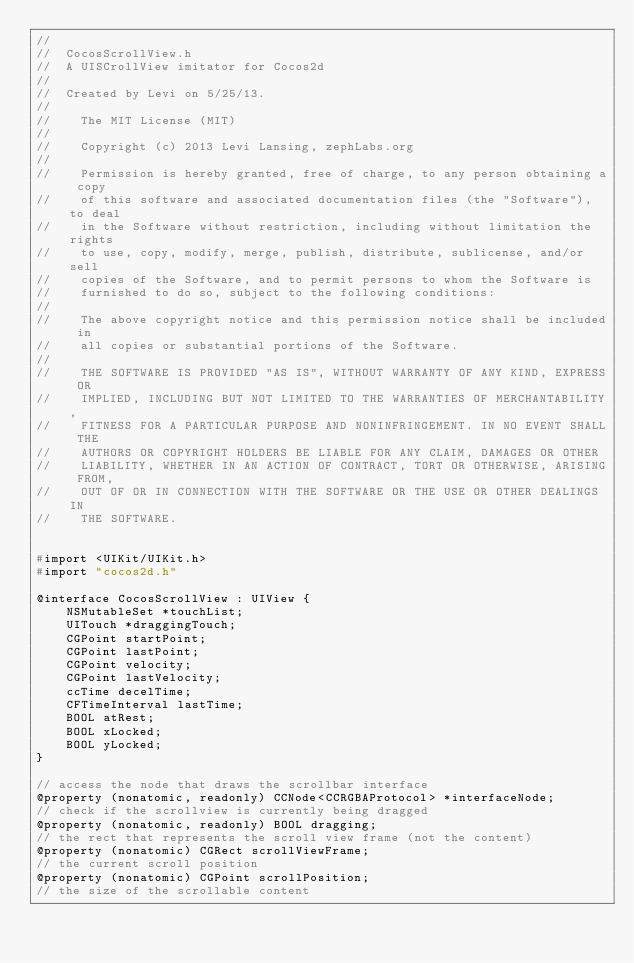Convert code to text. <code><loc_0><loc_0><loc_500><loc_500><_C_>//
//  CocosScrollView.h
//  A UISCrollView imitator for Cocos2d
//
//  Created by Levi on 5/25/13.
//
//    The MIT License (MIT)
//
//    Copyright (c) 2013 Levi Lansing, zephLabs.org
//
//    Permission is hereby granted, free of charge, to any person obtaining a copy
//    of this software and associated documentation files (the "Software"), to deal
//    in the Software without restriction, including without limitation the rights
//    to use, copy, modify, merge, publish, distribute, sublicense, and/or sell
//    copies of the Software, and to permit persons to whom the Software is
//    furnished to do so, subject to the following conditions:
//
//    The above copyright notice and this permission notice shall be included in
//    all copies or substantial portions of the Software.
//
//    THE SOFTWARE IS PROVIDED "AS IS", WITHOUT WARRANTY OF ANY KIND, EXPRESS OR
//    IMPLIED, INCLUDING BUT NOT LIMITED TO THE WARRANTIES OF MERCHANTABILITY,
//    FITNESS FOR A PARTICULAR PURPOSE AND NONINFRINGEMENT. IN NO EVENT SHALL THE
//    AUTHORS OR COPYRIGHT HOLDERS BE LIABLE FOR ANY CLAIM, DAMAGES OR OTHER
//    LIABILITY, WHETHER IN AN ACTION OF CONTRACT, TORT OR OTHERWISE, ARISING FROM,
//    OUT OF OR IN CONNECTION WITH THE SOFTWARE OR THE USE OR OTHER DEALINGS IN
//    THE SOFTWARE.


#import <UIKit/UIKit.h>
#import "cocos2d.h"

@interface CocosScrollView : UIView {
    NSMutableSet *touchList;
    UITouch *draggingTouch;
    CGPoint startPoint;
    CGPoint lastPoint;
    CGPoint velocity;
    CGPoint lastVelocity;
    ccTime decelTime;
    CFTimeInterval lastTime;
    BOOL atRest;
    BOOL xLocked;
    BOOL yLocked;
}

// access the node that draws the scrollbar interface
@property (nonatomic, readonly) CCNode<CCRGBAProtocol> *interfaceNode;
// check if the scrollview is currently being dragged
@property (nonatomic, readonly) BOOL dragging;
// the rect that represents the scroll view frame (not the content)
@property (nonatomic) CGRect scrollViewFrame;
// the current scroll position
@property (nonatomic) CGPoint scrollPosition;
// the size of the scrollable content</code> 